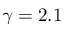<formula> <loc_0><loc_0><loc_500><loc_500>\gamma = 2 . 1</formula> 